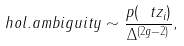Convert formula to latex. <formula><loc_0><loc_0><loc_500><loc_500>h o l . a m b i g u i t y \sim \frac { p ( \ t z _ { i } ) } { \Delta ^ { ( 2 g - 2 ) } } ,</formula> 